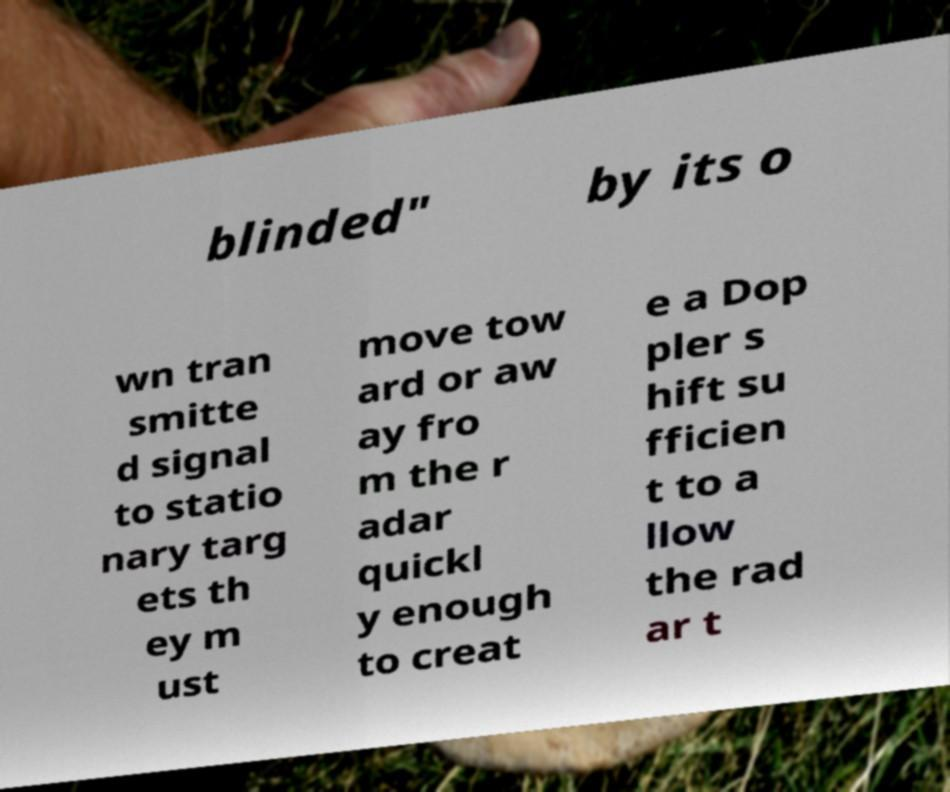For documentation purposes, I need the text within this image transcribed. Could you provide that? blinded" by its o wn tran smitte d signal to statio nary targ ets th ey m ust move tow ard or aw ay fro m the r adar quickl y enough to creat e a Dop pler s hift su fficien t to a llow the rad ar t 